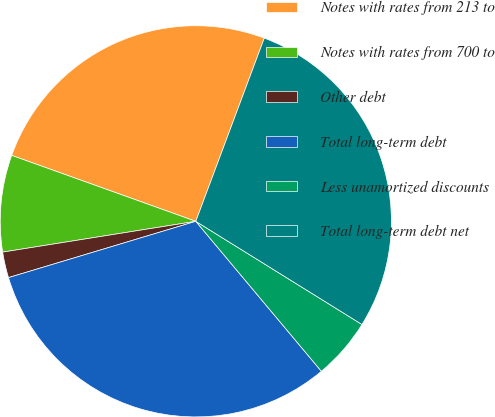<chart> <loc_0><loc_0><loc_500><loc_500><pie_chart><fcel>Notes with rates from 213 to<fcel>Notes with rates from 700 to<fcel>Other debt<fcel>Total long-term debt<fcel>Less unamortized discounts<fcel>Total long-term debt net<nl><fcel>25.22%<fcel>7.99%<fcel>2.13%<fcel>31.45%<fcel>5.06%<fcel>28.15%<nl></chart> 